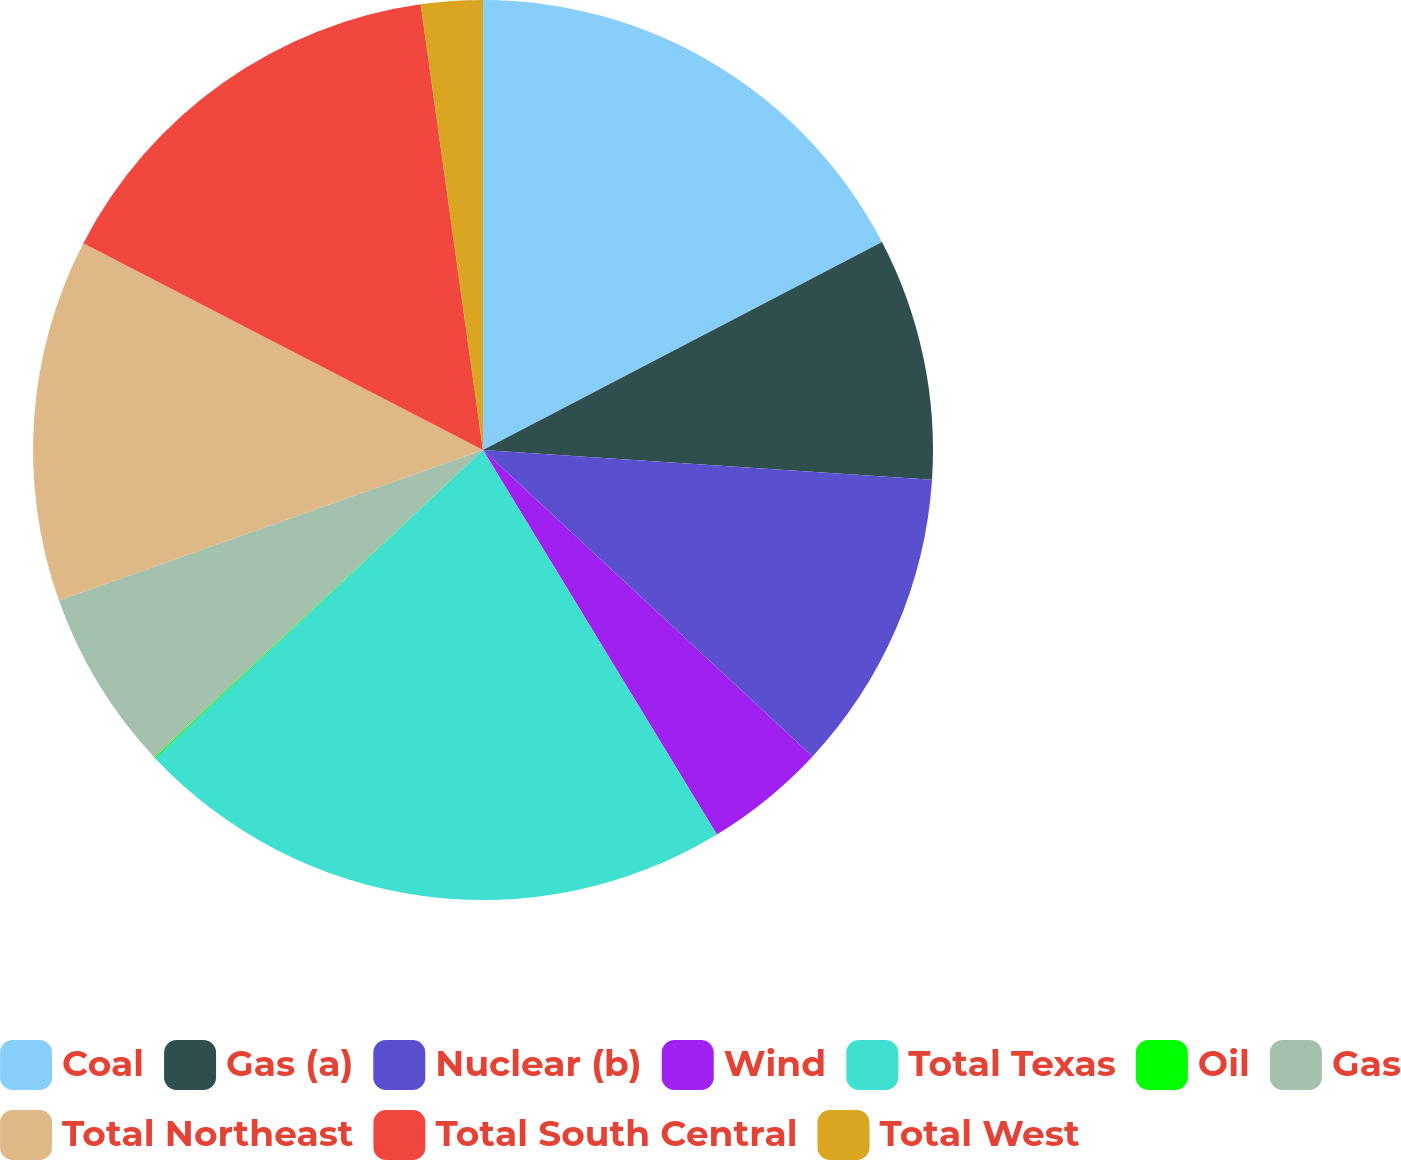Convert chart to OTSL. <chart><loc_0><loc_0><loc_500><loc_500><pie_chart><fcel>Coal<fcel>Gas (a)<fcel>Nuclear (b)<fcel>Wind<fcel>Total Texas<fcel>Oil<fcel>Gas<fcel>Total Northeast<fcel>Total South Central<fcel>Total West<nl><fcel>17.35%<fcel>8.7%<fcel>10.87%<fcel>4.38%<fcel>21.68%<fcel>0.05%<fcel>6.54%<fcel>13.03%<fcel>15.19%<fcel>2.21%<nl></chart> 